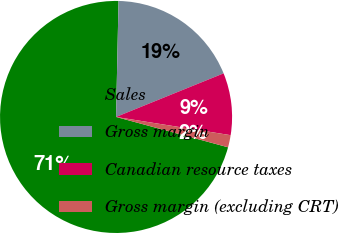Convert chart. <chart><loc_0><loc_0><loc_500><loc_500><pie_chart><fcel>Sales<fcel>Gross margin<fcel>Canadian resource taxes<fcel>Gross margin (excluding CRT)<nl><fcel>71.13%<fcel>18.53%<fcel>8.64%<fcel>1.7%<nl></chart> 